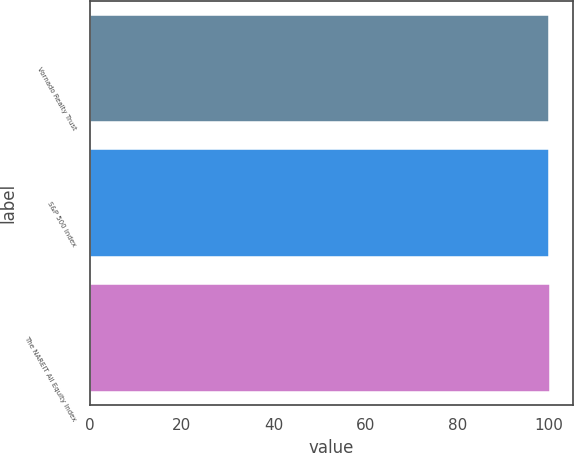Convert chart. <chart><loc_0><loc_0><loc_500><loc_500><bar_chart><fcel>Vornado Realty Trust<fcel>S&P 500 Index<fcel>The NAREIT All Equity Index<nl><fcel>100<fcel>100.1<fcel>100.2<nl></chart> 